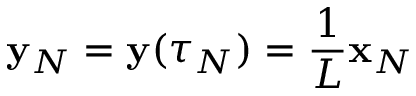Convert formula to latex. <formula><loc_0><loc_0><loc_500><loc_500>{ \mathbf y } _ { N } = { \mathbf y } ( \tau _ { N } ) = \frac { 1 } { L } { \mathbf x } _ { N }</formula> 